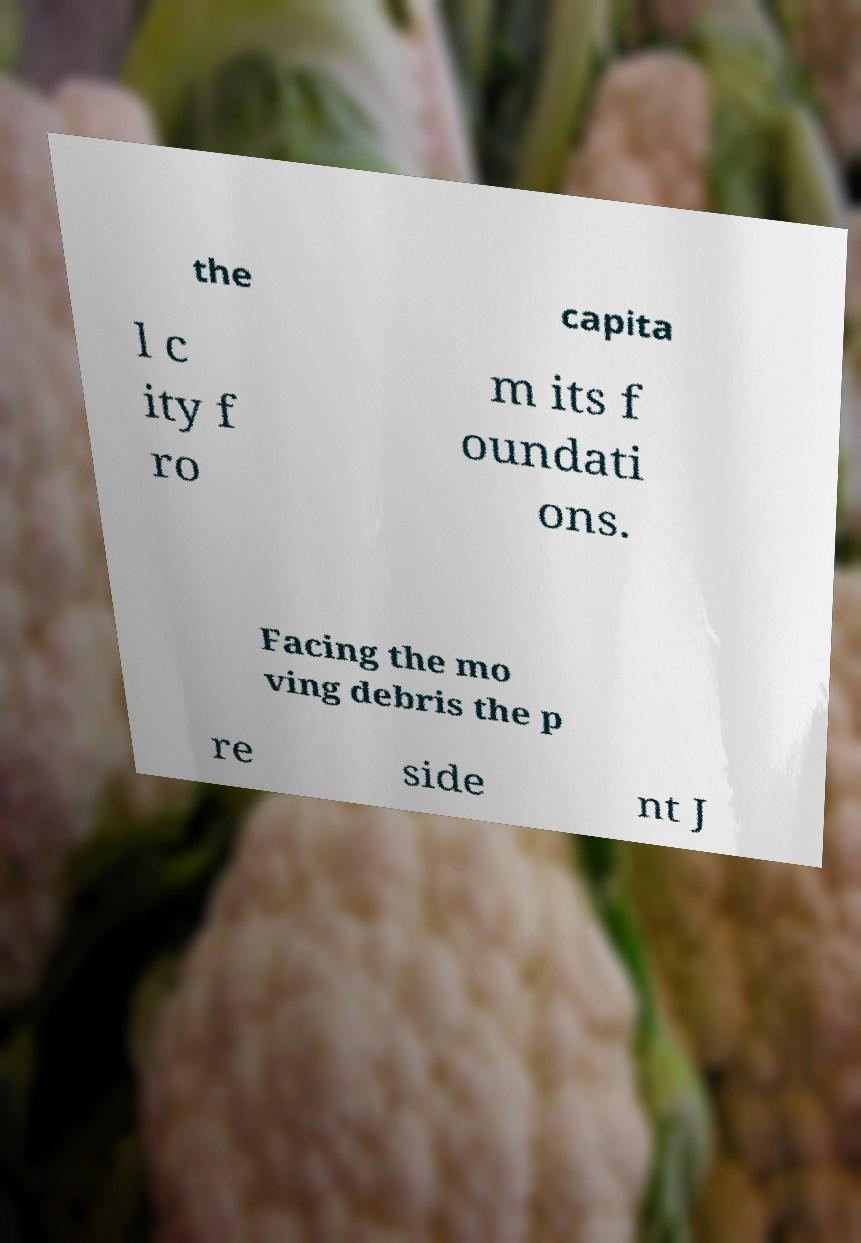Can you accurately transcribe the text from the provided image for me? the capita l c ity f ro m its f oundati ons. Facing the mo ving debris the p re side nt J 